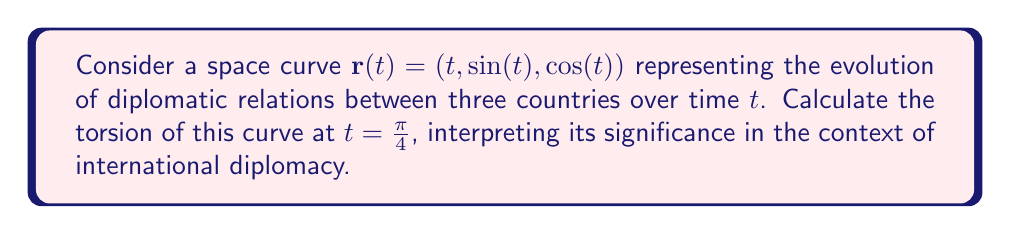Can you solve this math problem? To calculate the torsion of the curve, we'll follow these steps:

1) First, we need to find $\mathbf{r}'(t)$, $\mathbf{r}''(t)$, and $\mathbf{r}'''(t)$:

   $\mathbf{r}'(t) = (1, \cos(t), -\sin(t))$
   $\mathbf{r}''(t) = (0, -\sin(t), -\cos(t))$
   $\mathbf{r}'''(t) = (0, -\cos(t), \sin(t))$

2) The torsion $\tau$ is given by the formula:

   $$\tau = \frac{(\mathbf{r}' \times \mathbf{r}'') \cdot \mathbf{r}'''}{|\mathbf{r}' \times \mathbf{r}''|^2}$$

3) Let's calculate $\mathbf{r}' \times \mathbf{r}''$:

   $\mathbf{r}' \times \mathbf{r}'' = (1, \cos(t), -\sin(t)) \times (0, -\sin(t), -\cos(t))$
                                   $= (\cos^2(t) + \sin^2(t), \sin(t), \cos(t))$
                                   $= (1, \sin(t), \cos(t))$

4) Now, $(\mathbf{r}' \times \mathbf{r}'') \cdot \mathbf{r}'''$:

   $(1, \sin(t), \cos(t)) \cdot (0, -\cos(t), \sin(t)) = -\sin(t)\cos(t) + \cos(t)\sin(t) = 0$

5) This means that the torsion is zero for all $t$, including $t = \frac{\pi}{4}$.

In the context of international diplomacy, zero torsion indicates that the diplomatic relations between the three countries are evolving in a predictable, planar manner. This suggests a stable and consistent pattern of interactions, without sudden twists or complexities in their relationships.
Answer: $\tau = 0$ 